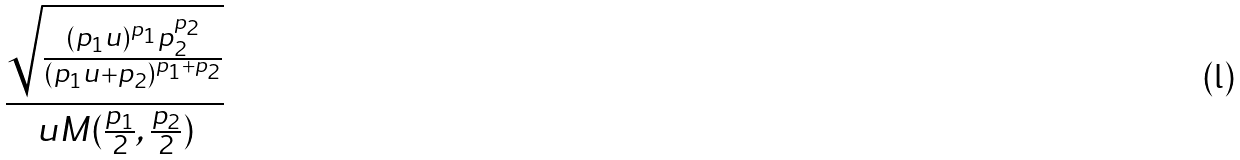<formula> <loc_0><loc_0><loc_500><loc_500>\frac { \sqrt { \frac { ( p _ { 1 } u ) ^ { p _ { 1 } } p _ { 2 } ^ { p _ { 2 } } } { ( p _ { 1 } u + p _ { 2 } ) ^ { p _ { 1 } + p _ { 2 } } } } } { u M ( \frac { p _ { 1 } } { 2 } , \frac { p _ { 2 } } { 2 } ) }</formula> 